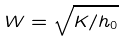<formula> <loc_0><loc_0><loc_500><loc_500>W = \sqrt { K / h _ { 0 } }</formula> 